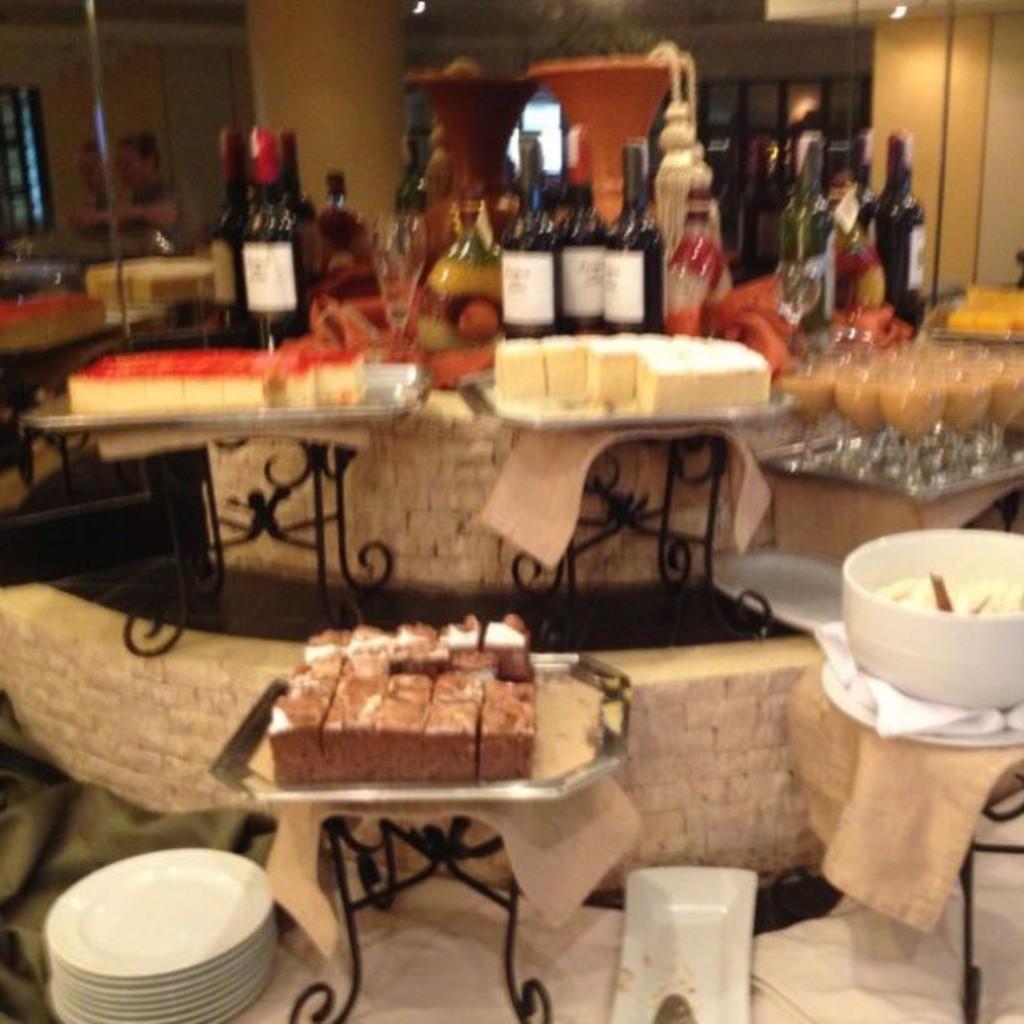How would you summarize this image in a sentence or two? In the foreground of this image, there are tables on which bottles, cakes, glasses, pot, and clothes are placed on it. On the bottom of this image, there are platters, food on the table. In the background, there are glasses, bottles, pillar, and the wall. 